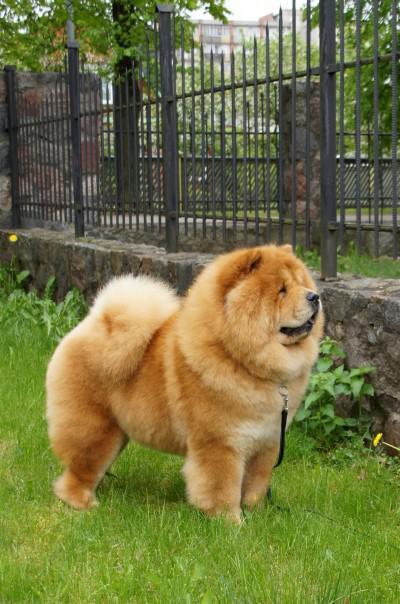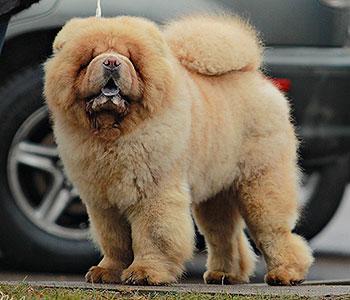The first image is the image on the left, the second image is the image on the right. Analyze the images presented: Is the assertion "The right image contains exactly one chow whose body is facing towards the left and their face is looking at the camera." valid? Answer yes or no. Yes. The first image is the image on the left, the second image is the image on the right. Considering the images on both sides, is "There are only two brown dogs in the pair of images." valid? Answer yes or no. Yes. 